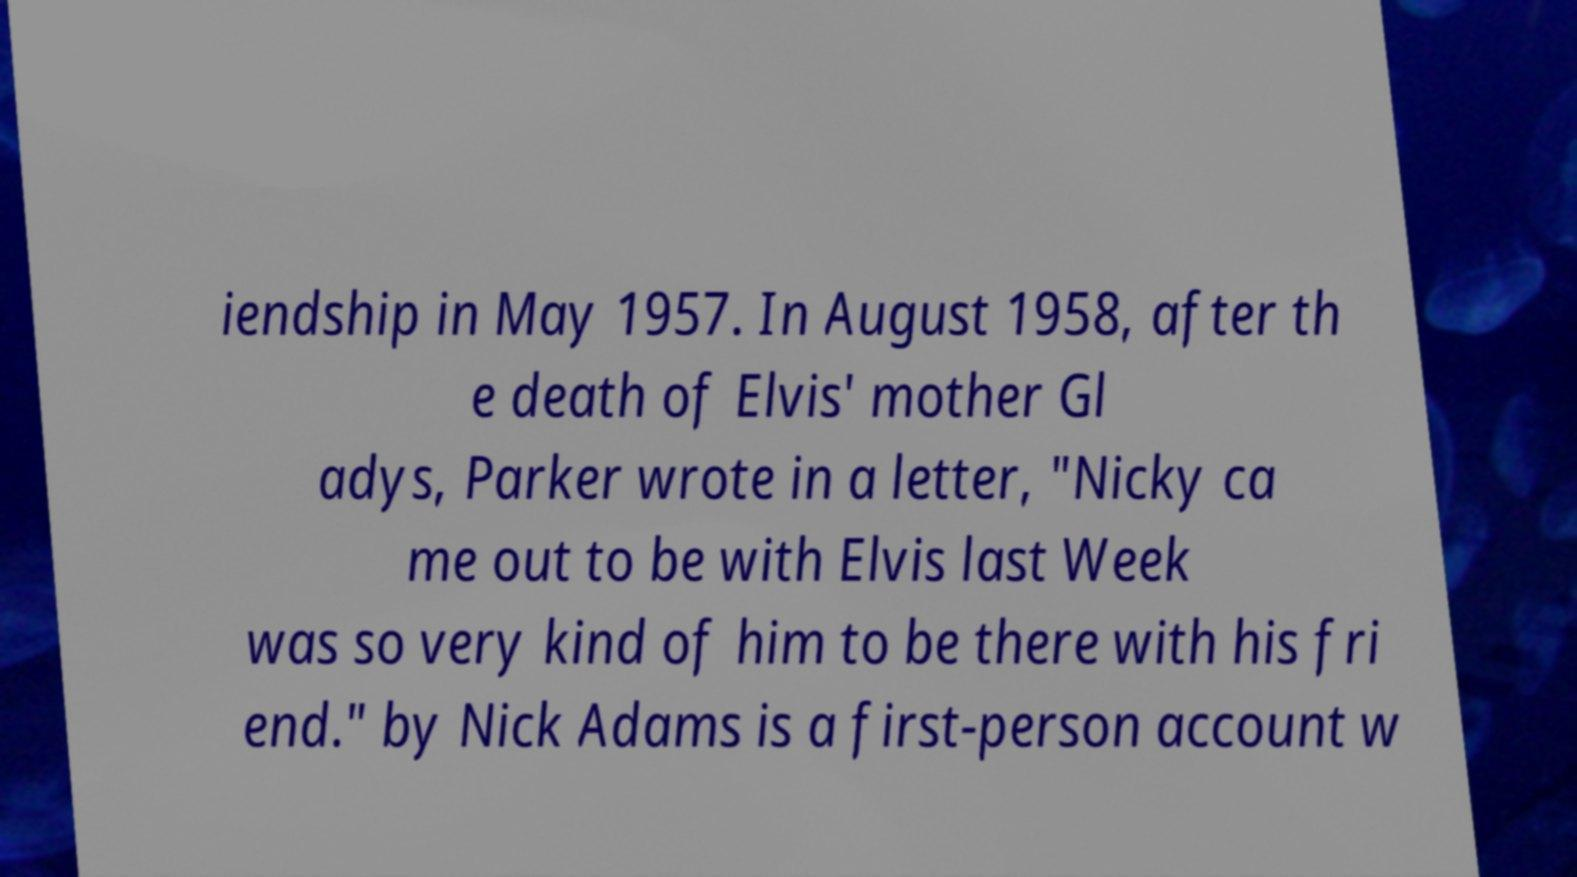Please read and relay the text visible in this image. What does it say? iendship in May 1957. In August 1958, after th e death of Elvis' mother Gl adys, Parker wrote in a letter, "Nicky ca me out to be with Elvis last Week was so very kind of him to be there with his fri end." by Nick Adams is a first-person account w 